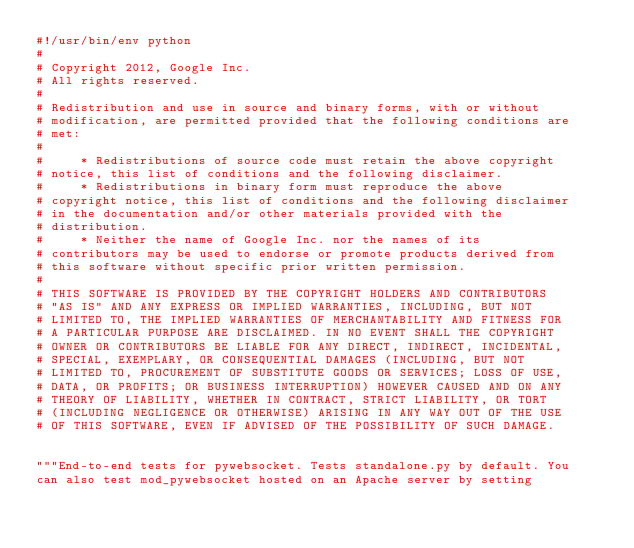Convert code to text. <code><loc_0><loc_0><loc_500><loc_500><_Python_>#!/usr/bin/env python
#
# Copyright 2012, Google Inc.
# All rights reserved.
#
# Redistribution and use in source and binary forms, with or without
# modification, are permitted provided that the following conditions are
# met:
#
#     * Redistributions of source code must retain the above copyright
# notice, this list of conditions and the following disclaimer.
#     * Redistributions in binary form must reproduce the above
# copyright notice, this list of conditions and the following disclaimer
# in the documentation and/or other materials provided with the
# distribution.
#     * Neither the name of Google Inc. nor the names of its
# contributors may be used to endorse or promote products derived from
# this software without specific prior written permission.
#
# THIS SOFTWARE IS PROVIDED BY THE COPYRIGHT HOLDERS AND CONTRIBUTORS
# "AS IS" AND ANY EXPRESS OR IMPLIED WARRANTIES, INCLUDING, BUT NOT
# LIMITED TO, THE IMPLIED WARRANTIES OF MERCHANTABILITY AND FITNESS FOR
# A PARTICULAR PURPOSE ARE DISCLAIMED. IN NO EVENT SHALL THE COPYRIGHT
# OWNER OR CONTRIBUTORS BE LIABLE FOR ANY DIRECT, INDIRECT, INCIDENTAL,
# SPECIAL, EXEMPLARY, OR CONSEQUENTIAL DAMAGES (INCLUDING, BUT NOT
# LIMITED TO, PROCUREMENT OF SUBSTITUTE GOODS OR SERVICES; LOSS OF USE,
# DATA, OR PROFITS; OR BUSINESS INTERRUPTION) HOWEVER CAUSED AND ON ANY
# THEORY OF LIABILITY, WHETHER IN CONTRACT, STRICT LIABILITY, OR TORT
# (INCLUDING NEGLIGENCE OR OTHERWISE) ARISING IN ANY WAY OUT OF THE USE
# OF THIS SOFTWARE, EVEN IF ADVISED OF THE POSSIBILITY OF SUCH DAMAGE.


"""End-to-end tests for pywebsocket. Tests standalone.py by default. You
can also test mod_pywebsocket hosted on an Apache server by setting</code> 